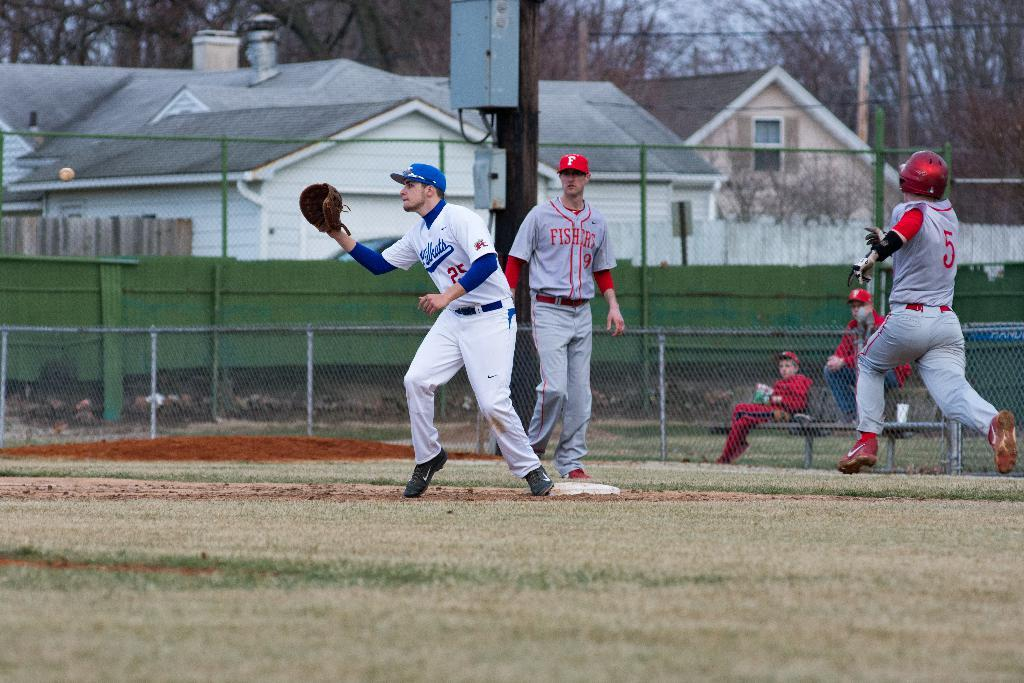<image>
Give a short and clear explanation of the subsequent image. number 25 is reaching to catch the ball in a baseball game 